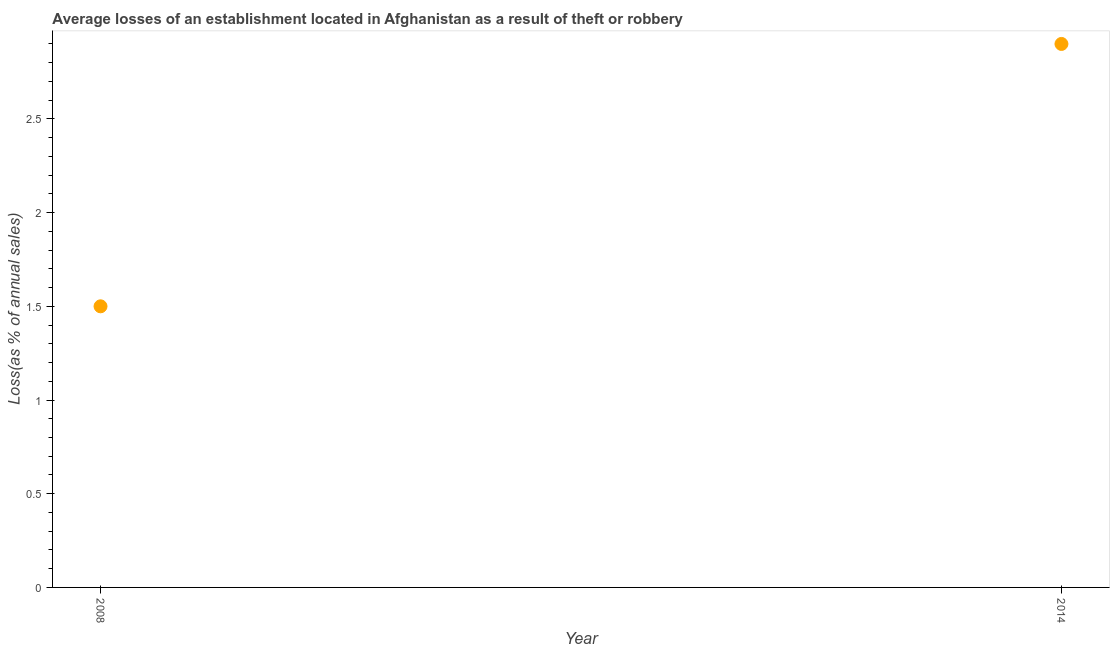What is the losses due to theft in 2008?
Offer a very short reply. 1.5. Across all years, what is the maximum losses due to theft?
Your response must be concise. 2.9. Across all years, what is the minimum losses due to theft?
Your answer should be very brief. 1.5. What is the sum of the losses due to theft?
Offer a very short reply. 4.4. What is the average losses due to theft per year?
Your response must be concise. 2.2. What is the median losses due to theft?
Make the answer very short. 2.2. In how many years, is the losses due to theft greater than 2.7 %?
Offer a very short reply. 1. Do a majority of the years between 2014 and 2008 (inclusive) have losses due to theft greater than 0.1 %?
Your answer should be compact. No. What is the ratio of the losses due to theft in 2008 to that in 2014?
Keep it short and to the point. 0.52. In how many years, is the losses due to theft greater than the average losses due to theft taken over all years?
Your answer should be compact. 1. How many years are there in the graph?
Your answer should be compact. 2. What is the difference between two consecutive major ticks on the Y-axis?
Offer a terse response. 0.5. Does the graph contain any zero values?
Your answer should be very brief. No. Does the graph contain grids?
Offer a very short reply. No. What is the title of the graph?
Your response must be concise. Average losses of an establishment located in Afghanistan as a result of theft or robbery. What is the label or title of the Y-axis?
Offer a terse response. Loss(as % of annual sales). What is the Loss(as % of annual sales) in 2008?
Ensure brevity in your answer.  1.5. What is the Loss(as % of annual sales) in 2014?
Provide a succinct answer. 2.9. What is the ratio of the Loss(as % of annual sales) in 2008 to that in 2014?
Provide a short and direct response. 0.52. 